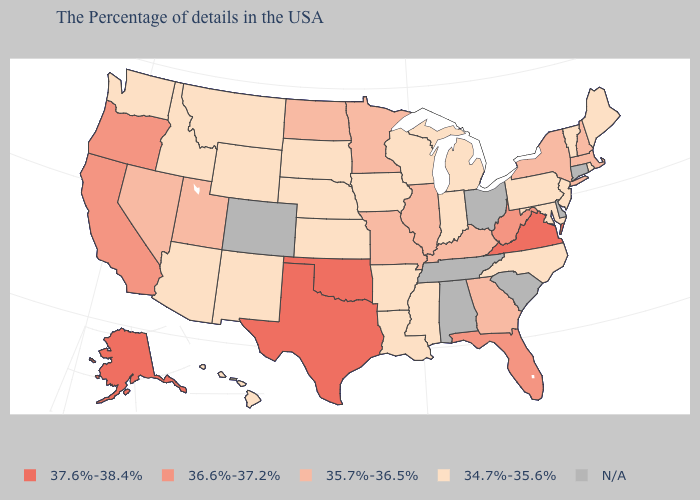Which states hav the highest value in the West?
Give a very brief answer. Alaska. Does Virginia have the highest value in the USA?
Keep it brief. Yes. What is the value of Connecticut?
Give a very brief answer. N/A. Name the states that have a value in the range 37.6%-38.4%?
Concise answer only. Virginia, Oklahoma, Texas, Alaska. What is the value of Texas?
Give a very brief answer. 37.6%-38.4%. Which states have the lowest value in the MidWest?
Give a very brief answer. Michigan, Indiana, Wisconsin, Iowa, Kansas, Nebraska, South Dakota. Does Idaho have the highest value in the West?
Write a very short answer. No. Among the states that border Connecticut , which have the lowest value?
Concise answer only. Rhode Island. Name the states that have a value in the range 37.6%-38.4%?
Write a very short answer. Virginia, Oklahoma, Texas, Alaska. What is the highest value in states that border Washington?
Short answer required. 36.6%-37.2%. Name the states that have a value in the range 37.6%-38.4%?
Be succinct. Virginia, Oklahoma, Texas, Alaska. What is the value of Maryland?
Short answer required. 34.7%-35.6%. How many symbols are there in the legend?
Answer briefly. 5. What is the lowest value in the USA?
Quick response, please. 34.7%-35.6%. 